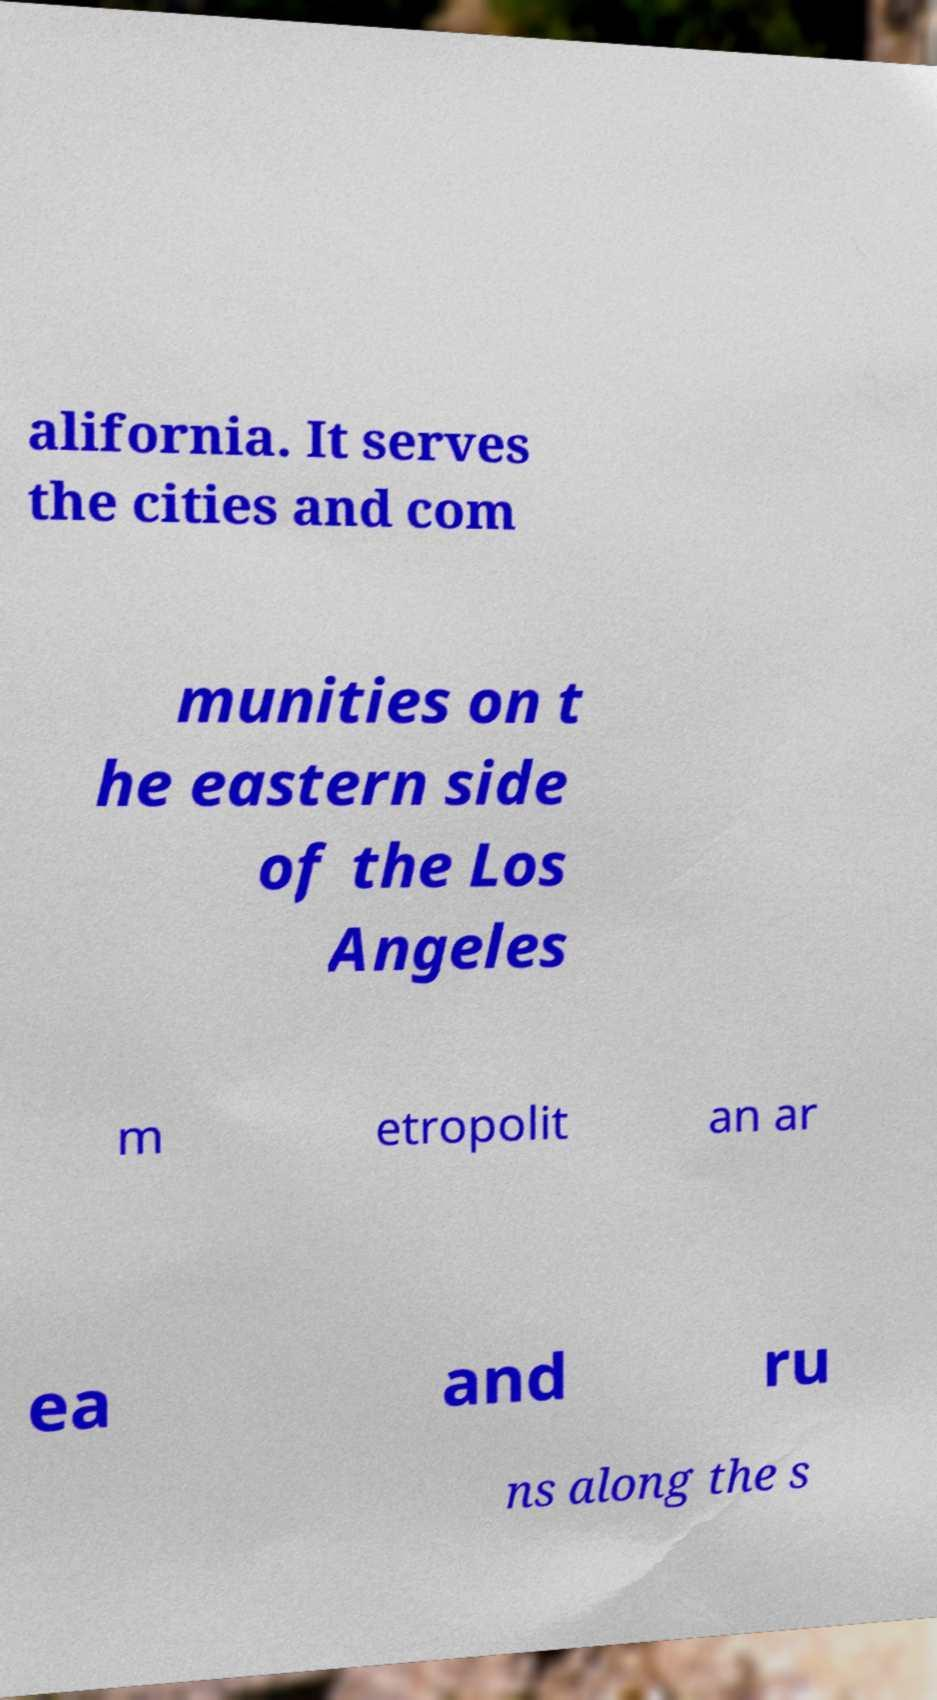What messages or text are displayed in this image? I need them in a readable, typed format. alifornia. It serves the cities and com munities on t he eastern side of the Los Angeles m etropolit an ar ea and ru ns along the s 